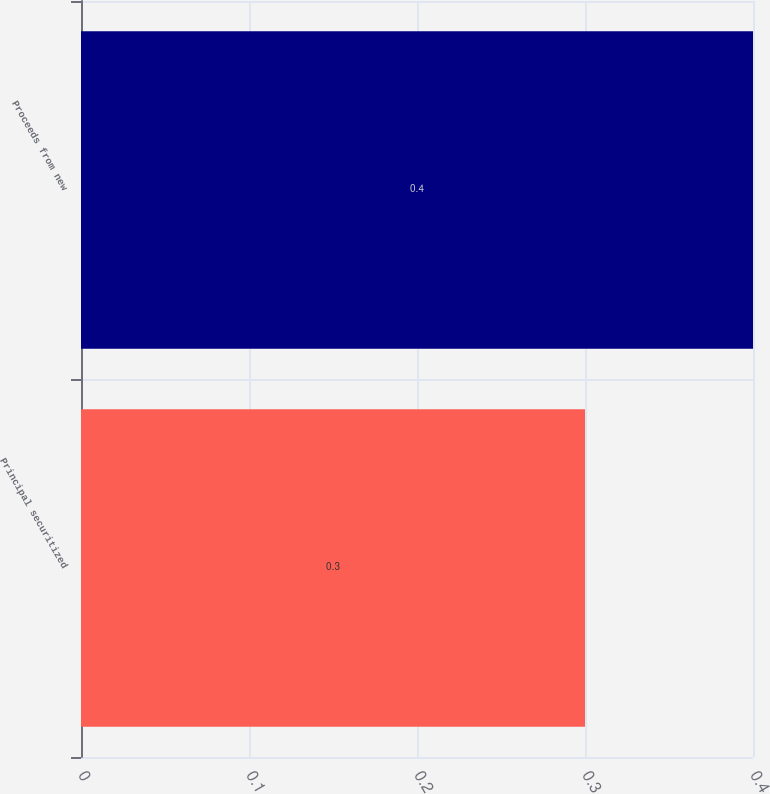Convert chart. <chart><loc_0><loc_0><loc_500><loc_500><bar_chart><fcel>Principal securitized<fcel>Proceeds from new<nl><fcel>0.3<fcel>0.4<nl></chart> 